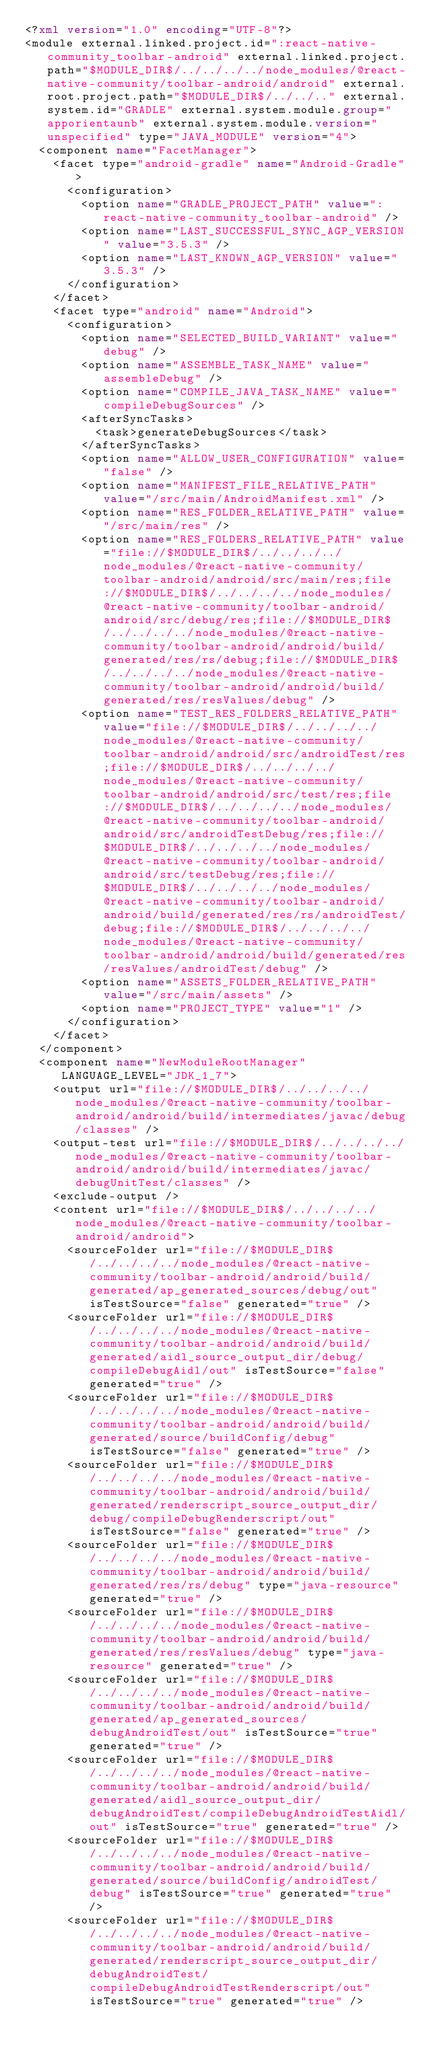Convert code to text. <code><loc_0><loc_0><loc_500><loc_500><_XML_><?xml version="1.0" encoding="UTF-8"?>
<module external.linked.project.id=":react-native-community_toolbar-android" external.linked.project.path="$MODULE_DIR$/../../../../node_modules/@react-native-community/toolbar-android/android" external.root.project.path="$MODULE_DIR$/../../.." external.system.id="GRADLE" external.system.module.group="apporientaunb" external.system.module.version="unspecified" type="JAVA_MODULE" version="4">
  <component name="FacetManager">
    <facet type="android-gradle" name="Android-Gradle">
      <configuration>
        <option name="GRADLE_PROJECT_PATH" value=":react-native-community_toolbar-android" />
        <option name="LAST_SUCCESSFUL_SYNC_AGP_VERSION" value="3.5.3" />
        <option name="LAST_KNOWN_AGP_VERSION" value="3.5.3" />
      </configuration>
    </facet>
    <facet type="android" name="Android">
      <configuration>
        <option name="SELECTED_BUILD_VARIANT" value="debug" />
        <option name="ASSEMBLE_TASK_NAME" value="assembleDebug" />
        <option name="COMPILE_JAVA_TASK_NAME" value="compileDebugSources" />
        <afterSyncTasks>
          <task>generateDebugSources</task>
        </afterSyncTasks>
        <option name="ALLOW_USER_CONFIGURATION" value="false" />
        <option name="MANIFEST_FILE_RELATIVE_PATH" value="/src/main/AndroidManifest.xml" />
        <option name="RES_FOLDER_RELATIVE_PATH" value="/src/main/res" />
        <option name="RES_FOLDERS_RELATIVE_PATH" value="file://$MODULE_DIR$/../../../../node_modules/@react-native-community/toolbar-android/android/src/main/res;file://$MODULE_DIR$/../../../../node_modules/@react-native-community/toolbar-android/android/src/debug/res;file://$MODULE_DIR$/../../../../node_modules/@react-native-community/toolbar-android/android/build/generated/res/rs/debug;file://$MODULE_DIR$/../../../../node_modules/@react-native-community/toolbar-android/android/build/generated/res/resValues/debug" />
        <option name="TEST_RES_FOLDERS_RELATIVE_PATH" value="file://$MODULE_DIR$/../../../../node_modules/@react-native-community/toolbar-android/android/src/androidTest/res;file://$MODULE_DIR$/../../../../node_modules/@react-native-community/toolbar-android/android/src/test/res;file://$MODULE_DIR$/../../../../node_modules/@react-native-community/toolbar-android/android/src/androidTestDebug/res;file://$MODULE_DIR$/../../../../node_modules/@react-native-community/toolbar-android/android/src/testDebug/res;file://$MODULE_DIR$/../../../../node_modules/@react-native-community/toolbar-android/android/build/generated/res/rs/androidTest/debug;file://$MODULE_DIR$/../../../../node_modules/@react-native-community/toolbar-android/android/build/generated/res/resValues/androidTest/debug" />
        <option name="ASSETS_FOLDER_RELATIVE_PATH" value="/src/main/assets" />
        <option name="PROJECT_TYPE" value="1" />
      </configuration>
    </facet>
  </component>
  <component name="NewModuleRootManager" LANGUAGE_LEVEL="JDK_1_7">
    <output url="file://$MODULE_DIR$/../../../../node_modules/@react-native-community/toolbar-android/android/build/intermediates/javac/debug/classes" />
    <output-test url="file://$MODULE_DIR$/../../../../node_modules/@react-native-community/toolbar-android/android/build/intermediates/javac/debugUnitTest/classes" />
    <exclude-output />
    <content url="file://$MODULE_DIR$/../../../../node_modules/@react-native-community/toolbar-android/android">
      <sourceFolder url="file://$MODULE_DIR$/../../../../node_modules/@react-native-community/toolbar-android/android/build/generated/ap_generated_sources/debug/out" isTestSource="false" generated="true" />
      <sourceFolder url="file://$MODULE_DIR$/../../../../node_modules/@react-native-community/toolbar-android/android/build/generated/aidl_source_output_dir/debug/compileDebugAidl/out" isTestSource="false" generated="true" />
      <sourceFolder url="file://$MODULE_DIR$/../../../../node_modules/@react-native-community/toolbar-android/android/build/generated/source/buildConfig/debug" isTestSource="false" generated="true" />
      <sourceFolder url="file://$MODULE_DIR$/../../../../node_modules/@react-native-community/toolbar-android/android/build/generated/renderscript_source_output_dir/debug/compileDebugRenderscript/out" isTestSource="false" generated="true" />
      <sourceFolder url="file://$MODULE_DIR$/../../../../node_modules/@react-native-community/toolbar-android/android/build/generated/res/rs/debug" type="java-resource" generated="true" />
      <sourceFolder url="file://$MODULE_DIR$/../../../../node_modules/@react-native-community/toolbar-android/android/build/generated/res/resValues/debug" type="java-resource" generated="true" />
      <sourceFolder url="file://$MODULE_DIR$/../../../../node_modules/@react-native-community/toolbar-android/android/build/generated/ap_generated_sources/debugAndroidTest/out" isTestSource="true" generated="true" />
      <sourceFolder url="file://$MODULE_DIR$/../../../../node_modules/@react-native-community/toolbar-android/android/build/generated/aidl_source_output_dir/debugAndroidTest/compileDebugAndroidTestAidl/out" isTestSource="true" generated="true" />
      <sourceFolder url="file://$MODULE_DIR$/../../../../node_modules/@react-native-community/toolbar-android/android/build/generated/source/buildConfig/androidTest/debug" isTestSource="true" generated="true" />
      <sourceFolder url="file://$MODULE_DIR$/../../../../node_modules/@react-native-community/toolbar-android/android/build/generated/renderscript_source_output_dir/debugAndroidTest/compileDebugAndroidTestRenderscript/out" isTestSource="true" generated="true" /></code> 